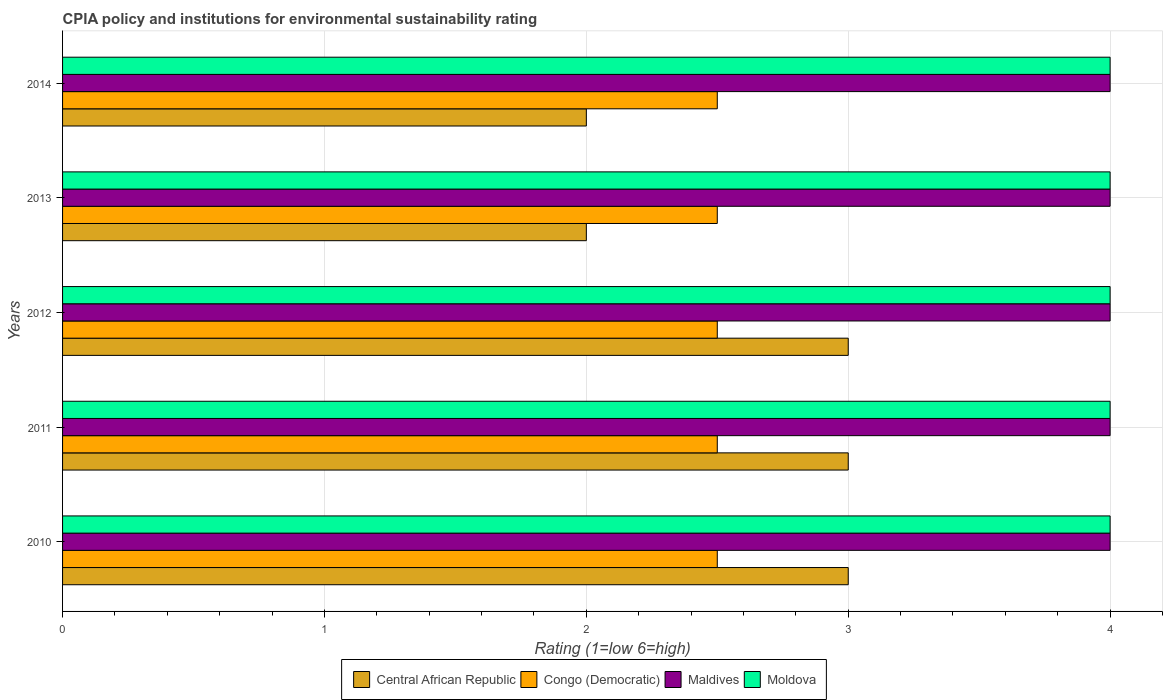How many different coloured bars are there?
Offer a very short reply. 4. Are the number of bars per tick equal to the number of legend labels?
Give a very brief answer. Yes. What is the label of the 5th group of bars from the top?
Offer a very short reply. 2010. What is the CPIA rating in Maldives in 2012?
Keep it short and to the point. 4. Across all years, what is the minimum CPIA rating in Moldova?
Keep it short and to the point. 4. In the year 2014, what is the difference between the CPIA rating in Congo (Democratic) and CPIA rating in Central African Republic?
Your response must be concise. 0.5. What is the ratio of the CPIA rating in Moldova in 2013 to that in 2014?
Make the answer very short. 1. Is the difference between the CPIA rating in Congo (Democratic) in 2011 and 2012 greater than the difference between the CPIA rating in Central African Republic in 2011 and 2012?
Make the answer very short. No. What is the difference between the highest and the second highest CPIA rating in Maldives?
Your answer should be compact. 0. In how many years, is the CPIA rating in Moldova greater than the average CPIA rating in Moldova taken over all years?
Your answer should be very brief. 0. Is the sum of the CPIA rating in Maldives in 2011 and 2012 greater than the maximum CPIA rating in Congo (Democratic) across all years?
Offer a terse response. Yes. What does the 4th bar from the top in 2014 represents?
Provide a succinct answer. Central African Republic. What does the 3rd bar from the bottom in 2013 represents?
Ensure brevity in your answer.  Maldives. Are all the bars in the graph horizontal?
Ensure brevity in your answer.  Yes. What is the difference between two consecutive major ticks on the X-axis?
Give a very brief answer. 1. Does the graph contain grids?
Offer a very short reply. Yes. How many legend labels are there?
Provide a succinct answer. 4. How are the legend labels stacked?
Provide a short and direct response. Horizontal. What is the title of the graph?
Make the answer very short. CPIA policy and institutions for environmental sustainability rating. Does "Eritrea" appear as one of the legend labels in the graph?
Your response must be concise. No. What is the Rating (1=low 6=high) in Congo (Democratic) in 2010?
Keep it short and to the point. 2.5. What is the Rating (1=low 6=high) in Maldives in 2010?
Provide a short and direct response. 4. What is the Rating (1=low 6=high) in Congo (Democratic) in 2011?
Your response must be concise. 2.5. What is the Rating (1=low 6=high) in Moldova in 2011?
Your answer should be compact. 4. What is the Rating (1=low 6=high) of Maldives in 2012?
Keep it short and to the point. 4. What is the Rating (1=low 6=high) of Moldova in 2012?
Make the answer very short. 4. What is the Rating (1=low 6=high) of Maldives in 2014?
Provide a short and direct response. 4. Across all years, what is the maximum Rating (1=low 6=high) of Central African Republic?
Your response must be concise. 3. Across all years, what is the minimum Rating (1=low 6=high) in Congo (Democratic)?
Your response must be concise. 2.5. What is the total Rating (1=low 6=high) of Congo (Democratic) in the graph?
Your response must be concise. 12.5. What is the total Rating (1=low 6=high) in Maldives in the graph?
Offer a very short reply. 20. What is the difference between the Rating (1=low 6=high) in Maldives in 2010 and that in 2011?
Offer a terse response. 0. What is the difference between the Rating (1=low 6=high) of Central African Republic in 2010 and that in 2012?
Provide a short and direct response. 0. What is the difference between the Rating (1=low 6=high) in Congo (Democratic) in 2010 and that in 2012?
Offer a very short reply. 0. What is the difference between the Rating (1=low 6=high) in Maldives in 2010 and that in 2013?
Your answer should be very brief. 0. What is the difference between the Rating (1=low 6=high) of Moldova in 2010 and that in 2013?
Ensure brevity in your answer.  0. What is the difference between the Rating (1=low 6=high) in Maldives in 2010 and that in 2014?
Your response must be concise. 0. What is the difference between the Rating (1=low 6=high) of Moldova in 2010 and that in 2014?
Make the answer very short. 0. What is the difference between the Rating (1=low 6=high) in Central African Republic in 2011 and that in 2012?
Offer a very short reply. 0. What is the difference between the Rating (1=low 6=high) in Congo (Democratic) in 2011 and that in 2012?
Give a very brief answer. 0. What is the difference between the Rating (1=low 6=high) of Maldives in 2011 and that in 2012?
Your answer should be compact. 0. What is the difference between the Rating (1=low 6=high) of Central African Republic in 2011 and that in 2013?
Keep it short and to the point. 1. What is the difference between the Rating (1=low 6=high) of Maldives in 2011 and that in 2013?
Provide a succinct answer. 0. What is the difference between the Rating (1=low 6=high) in Moldova in 2011 and that in 2013?
Keep it short and to the point. 0. What is the difference between the Rating (1=low 6=high) of Central African Republic in 2011 and that in 2014?
Give a very brief answer. 1. What is the difference between the Rating (1=low 6=high) of Congo (Democratic) in 2011 and that in 2014?
Give a very brief answer. 0. What is the difference between the Rating (1=low 6=high) of Central African Republic in 2012 and that in 2013?
Offer a terse response. 1. What is the difference between the Rating (1=low 6=high) of Moldova in 2012 and that in 2013?
Offer a very short reply. 0. What is the difference between the Rating (1=low 6=high) of Central African Republic in 2013 and that in 2014?
Make the answer very short. 0. What is the difference between the Rating (1=low 6=high) of Congo (Democratic) in 2013 and that in 2014?
Provide a succinct answer. 0. What is the difference between the Rating (1=low 6=high) in Moldova in 2013 and that in 2014?
Your answer should be very brief. 0. What is the difference between the Rating (1=low 6=high) in Central African Republic in 2010 and the Rating (1=low 6=high) in Maldives in 2011?
Provide a succinct answer. -1. What is the difference between the Rating (1=low 6=high) in Congo (Democratic) in 2010 and the Rating (1=low 6=high) in Maldives in 2011?
Your answer should be compact. -1.5. What is the difference between the Rating (1=low 6=high) in Central African Republic in 2010 and the Rating (1=low 6=high) in Congo (Democratic) in 2012?
Your answer should be compact. 0.5. What is the difference between the Rating (1=low 6=high) in Central African Republic in 2010 and the Rating (1=low 6=high) in Maldives in 2012?
Provide a short and direct response. -1. What is the difference between the Rating (1=low 6=high) of Central African Republic in 2010 and the Rating (1=low 6=high) of Moldova in 2012?
Keep it short and to the point. -1. What is the difference between the Rating (1=low 6=high) in Congo (Democratic) in 2010 and the Rating (1=low 6=high) in Maldives in 2012?
Give a very brief answer. -1.5. What is the difference between the Rating (1=low 6=high) in Maldives in 2010 and the Rating (1=low 6=high) in Moldova in 2012?
Ensure brevity in your answer.  0. What is the difference between the Rating (1=low 6=high) in Central African Republic in 2010 and the Rating (1=low 6=high) in Congo (Democratic) in 2013?
Offer a terse response. 0.5. What is the difference between the Rating (1=low 6=high) of Congo (Democratic) in 2010 and the Rating (1=low 6=high) of Maldives in 2013?
Give a very brief answer. -1.5. What is the difference between the Rating (1=low 6=high) in Congo (Democratic) in 2010 and the Rating (1=low 6=high) in Moldova in 2013?
Make the answer very short. -1.5. What is the difference between the Rating (1=low 6=high) of Maldives in 2010 and the Rating (1=low 6=high) of Moldova in 2013?
Offer a terse response. 0. What is the difference between the Rating (1=low 6=high) in Central African Republic in 2010 and the Rating (1=low 6=high) in Congo (Democratic) in 2014?
Give a very brief answer. 0.5. What is the difference between the Rating (1=low 6=high) in Congo (Democratic) in 2010 and the Rating (1=low 6=high) in Maldives in 2014?
Give a very brief answer. -1.5. What is the difference between the Rating (1=low 6=high) in Central African Republic in 2011 and the Rating (1=low 6=high) in Maldives in 2012?
Give a very brief answer. -1. What is the difference between the Rating (1=low 6=high) of Central African Republic in 2011 and the Rating (1=low 6=high) of Moldova in 2012?
Your answer should be compact. -1. What is the difference between the Rating (1=low 6=high) of Central African Republic in 2011 and the Rating (1=low 6=high) of Congo (Democratic) in 2013?
Your answer should be compact. 0.5. What is the difference between the Rating (1=low 6=high) of Central African Republic in 2011 and the Rating (1=low 6=high) of Moldova in 2013?
Your answer should be compact. -1. What is the difference between the Rating (1=low 6=high) of Central African Republic in 2012 and the Rating (1=low 6=high) of Congo (Democratic) in 2013?
Your answer should be very brief. 0.5. What is the difference between the Rating (1=low 6=high) in Central African Republic in 2012 and the Rating (1=low 6=high) in Maldives in 2013?
Give a very brief answer. -1. What is the difference between the Rating (1=low 6=high) in Congo (Democratic) in 2012 and the Rating (1=low 6=high) in Maldives in 2013?
Your answer should be very brief. -1.5. What is the difference between the Rating (1=low 6=high) of Maldives in 2012 and the Rating (1=low 6=high) of Moldova in 2013?
Give a very brief answer. 0. What is the difference between the Rating (1=low 6=high) of Central African Republic in 2012 and the Rating (1=low 6=high) of Maldives in 2014?
Offer a very short reply. -1. What is the difference between the Rating (1=low 6=high) of Central African Republic in 2012 and the Rating (1=low 6=high) of Moldova in 2014?
Offer a terse response. -1. What is the difference between the Rating (1=low 6=high) in Congo (Democratic) in 2012 and the Rating (1=low 6=high) in Moldova in 2014?
Your answer should be very brief. -1.5. What is the difference between the Rating (1=low 6=high) of Maldives in 2012 and the Rating (1=low 6=high) of Moldova in 2014?
Provide a succinct answer. 0. What is the difference between the Rating (1=low 6=high) in Central African Republic in 2013 and the Rating (1=low 6=high) in Maldives in 2014?
Provide a short and direct response. -2. What is the difference between the Rating (1=low 6=high) of Central African Republic in 2013 and the Rating (1=low 6=high) of Moldova in 2014?
Your answer should be compact. -2. What is the difference between the Rating (1=low 6=high) of Congo (Democratic) in 2013 and the Rating (1=low 6=high) of Maldives in 2014?
Ensure brevity in your answer.  -1.5. What is the average Rating (1=low 6=high) in Central African Republic per year?
Ensure brevity in your answer.  2.6. What is the average Rating (1=low 6=high) of Congo (Democratic) per year?
Offer a very short reply. 2.5. What is the average Rating (1=low 6=high) of Moldova per year?
Provide a short and direct response. 4. In the year 2010, what is the difference between the Rating (1=low 6=high) of Central African Republic and Rating (1=low 6=high) of Maldives?
Offer a terse response. -1. In the year 2010, what is the difference between the Rating (1=low 6=high) in Central African Republic and Rating (1=low 6=high) in Moldova?
Make the answer very short. -1. In the year 2010, what is the difference between the Rating (1=low 6=high) in Congo (Democratic) and Rating (1=low 6=high) in Moldova?
Your answer should be compact. -1.5. In the year 2010, what is the difference between the Rating (1=low 6=high) of Maldives and Rating (1=low 6=high) of Moldova?
Ensure brevity in your answer.  0. In the year 2011, what is the difference between the Rating (1=low 6=high) of Central African Republic and Rating (1=low 6=high) of Maldives?
Give a very brief answer. -1. In the year 2011, what is the difference between the Rating (1=low 6=high) of Congo (Democratic) and Rating (1=low 6=high) of Maldives?
Give a very brief answer. -1.5. In the year 2011, what is the difference between the Rating (1=low 6=high) in Congo (Democratic) and Rating (1=low 6=high) in Moldova?
Provide a succinct answer. -1.5. In the year 2012, what is the difference between the Rating (1=low 6=high) of Central African Republic and Rating (1=low 6=high) of Congo (Democratic)?
Your answer should be very brief. 0.5. In the year 2012, what is the difference between the Rating (1=low 6=high) of Congo (Democratic) and Rating (1=low 6=high) of Maldives?
Ensure brevity in your answer.  -1.5. In the year 2012, what is the difference between the Rating (1=low 6=high) of Maldives and Rating (1=low 6=high) of Moldova?
Ensure brevity in your answer.  0. In the year 2013, what is the difference between the Rating (1=low 6=high) of Central African Republic and Rating (1=low 6=high) of Maldives?
Your response must be concise. -2. In the year 2013, what is the difference between the Rating (1=low 6=high) of Congo (Democratic) and Rating (1=low 6=high) of Maldives?
Offer a terse response. -1.5. In the year 2013, what is the difference between the Rating (1=low 6=high) of Maldives and Rating (1=low 6=high) of Moldova?
Your answer should be very brief. 0. In the year 2014, what is the difference between the Rating (1=low 6=high) in Central African Republic and Rating (1=low 6=high) in Maldives?
Your response must be concise. -2. In the year 2014, what is the difference between the Rating (1=low 6=high) in Congo (Democratic) and Rating (1=low 6=high) in Maldives?
Provide a short and direct response. -1.5. What is the ratio of the Rating (1=low 6=high) in Congo (Democratic) in 2010 to that in 2011?
Provide a short and direct response. 1. What is the ratio of the Rating (1=low 6=high) in Maldives in 2010 to that in 2011?
Offer a very short reply. 1. What is the ratio of the Rating (1=low 6=high) of Central African Republic in 2010 to that in 2012?
Keep it short and to the point. 1. What is the ratio of the Rating (1=low 6=high) in Moldova in 2010 to that in 2012?
Offer a terse response. 1. What is the ratio of the Rating (1=low 6=high) in Central African Republic in 2010 to that in 2013?
Keep it short and to the point. 1.5. What is the ratio of the Rating (1=low 6=high) of Maldives in 2010 to that in 2013?
Your answer should be compact. 1. What is the ratio of the Rating (1=low 6=high) in Central African Republic in 2010 to that in 2014?
Offer a very short reply. 1.5. What is the ratio of the Rating (1=low 6=high) of Congo (Democratic) in 2010 to that in 2014?
Provide a short and direct response. 1. What is the ratio of the Rating (1=low 6=high) of Moldova in 2010 to that in 2014?
Your answer should be very brief. 1. What is the ratio of the Rating (1=low 6=high) of Central African Republic in 2011 to that in 2012?
Offer a terse response. 1. What is the ratio of the Rating (1=low 6=high) of Congo (Democratic) in 2011 to that in 2012?
Ensure brevity in your answer.  1. What is the ratio of the Rating (1=low 6=high) in Maldives in 2011 to that in 2012?
Keep it short and to the point. 1. What is the ratio of the Rating (1=low 6=high) in Moldova in 2011 to that in 2012?
Your answer should be compact. 1. What is the ratio of the Rating (1=low 6=high) of Central African Republic in 2011 to that in 2013?
Ensure brevity in your answer.  1.5. What is the ratio of the Rating (1=low 6=high) of Maldives in 2011 to that in 2013?
Offer a very short reply. 1. What is the ratio of the Rating (1=low 6=high) in Maldives in 2011 to that in 2014?
Offer a terse response. 1. What is the ratio of the Rating (1=low 6=high) of Congo (Democratic) in 2012 to that in 2013?
Provide a short and direct response. 1. What is the ratio of the Rating (1=low 6=high) in Maldives in 2012 to that in 2013?
Your answer should be very brief. 1. What is the ratio of the Rating (1=low 6=high) of Moldova in 2012 to that in 2013?
Keep it short and to the point. 1. What is the ratio of the Rating (1=low 6=high) of Central African Republic in 2012 to that in 2014?
Offer a very short reply. 1.5. What is the ratio of the Rating (1=low 6=high) of Congo (Democratic) in 2012 to that in 2014?
Keep it short and to the point. 1. What is the ratio of the Rating (1=low 6=high) in Moldova in 2012 to that in 2014?
Keep it short and to the point. 1. What is the difference between the highest and the second highest Rating (1=low 6=high) in Congo (Democratic)?
Give a very brief answer. 0. What is the difference between the highest and the second highest Rating (1=low 6=high) in Maldives?
Offer a very short reply. 0. What is the difference between the highest and the second highest Rating (1=low 6=high) in Moldova?
Make the answer very short. 0. What is the difference between the highest and the lowest Rating (1=low 6=high) in Congo (Democratic)?
Your answer should be compact. 0. What is the difference between the highest and the lowest Rating (1=low 6=high) in Maldives?
Your answer should be very brief. 0. What is the difference between the highest and the lowest Rating (1=low 6=high) in Moldova?
Make the answer very short. 0. 